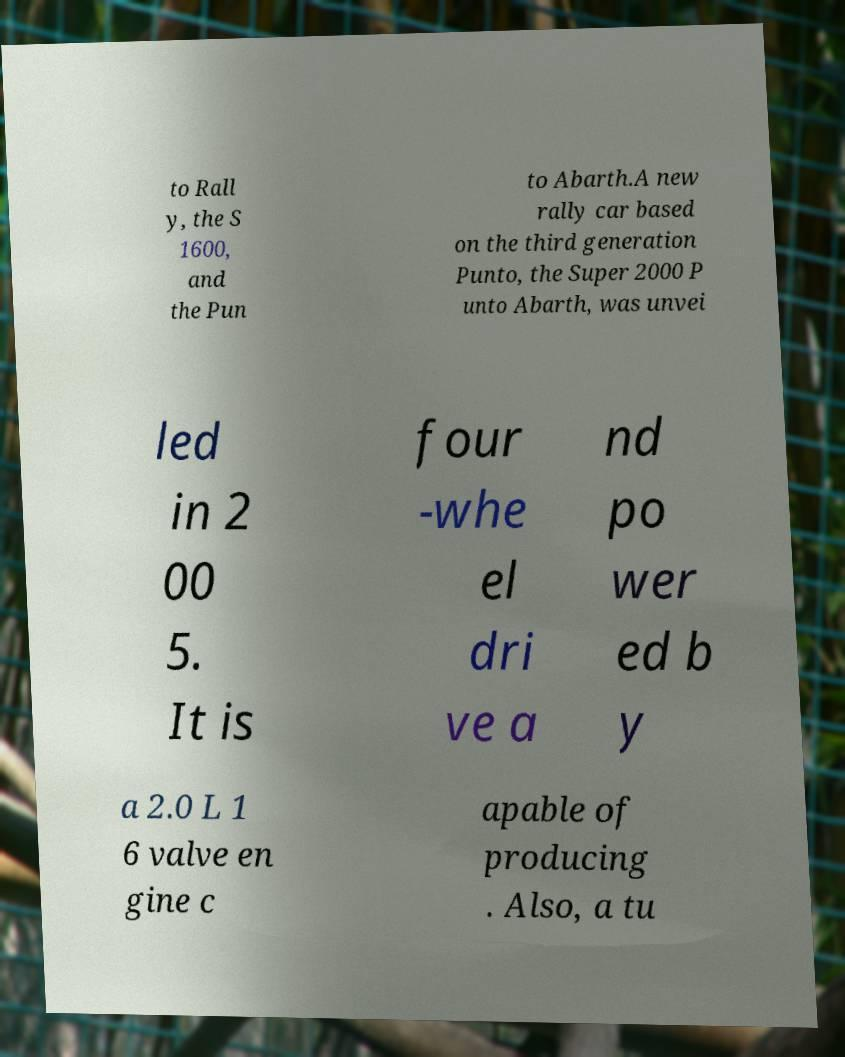What messages or text are displayed in this image? I need them in a readable, typed format. to Rall y, the S 1600, and the Pun to Abarth.A new rally car based on the third generation Punto, the Super 2000 P unto Abarth, was unvei led in 2 00 5. It is four -whe el dri ve a nd po wer ed b y a 2.0 L 1 6 valve en gine c apable of producing . Also, a tu 